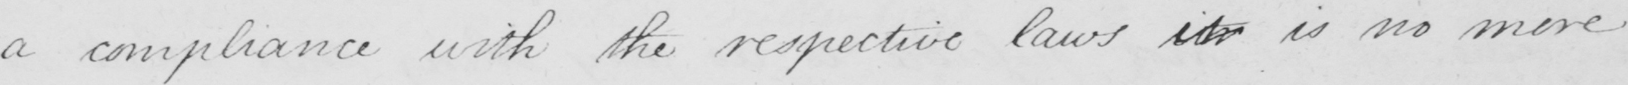Please transcribe the handwritten text in this image. being a compliance with the respective laws it is no more 